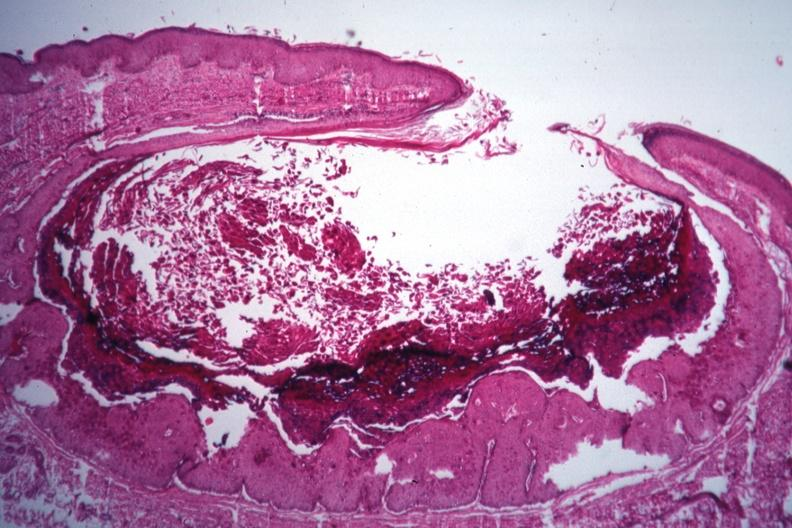where is this?
Answer the question using a single word or phrase. Skin 